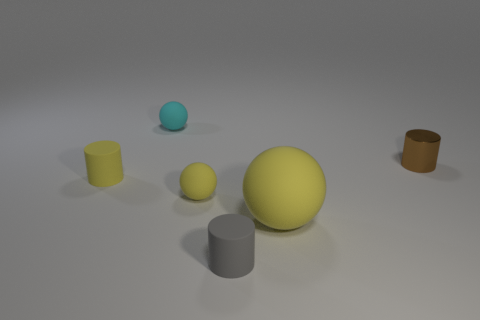There is a yellow ball that is the same size as the brown metal thing; what is it made of?
Ensure brevity in your answer.  Rubber. How many small objects are behind the large yellow matte object?
Keep it short and to the point. 4. Is the shape of the matte object in front of the large object the same as  the cyan object?
Keep it short and to the point. No. Are there any cyan rubber things of the same shape as the large yellow matte thing?
Keep it short and to the point. Yes. What material is the tiny cylinder that is the same color as the big sphere?
Offer a terse response. Rubber. There is a small matte object that is to the right of the tiny sphere that is to the right of the tiny cyan rubber object; what shape is it?
Your answer should be very brief. Cylinder. What number of tiny yellow cylinders have the same material as the tiny yellow ball?
Your response must be concise. 1. What is the color of the cylinder that is made of the same material as the tiny gray object?
Offer a very short reply. Yellow. There is a cylinder behind the yellow object that is behind the yellow ball that is to the left of the gray rubber cylinder; what size is it?
Make the answer very short. Small. Is the number of tiny metallic balls less than the number of tiny things?
Offer a terse response. Yes. 